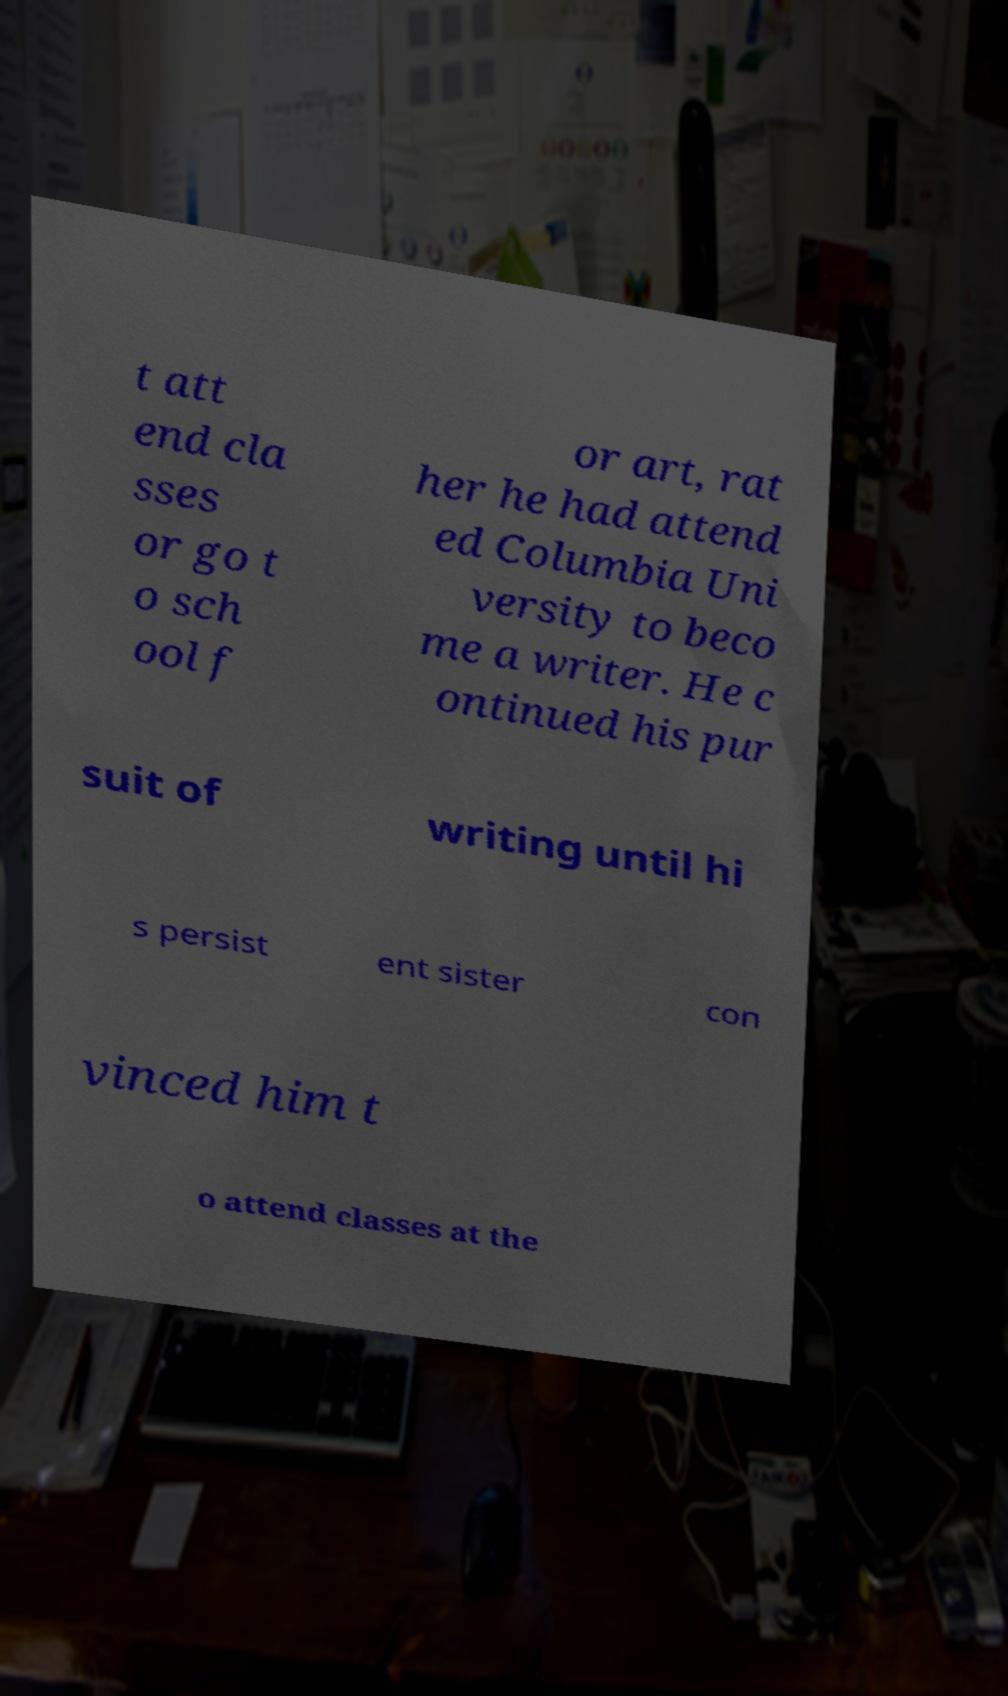Please read and relay the text visible in this image. What does it say? t att end cla sses or go t o sch ool f or art, rat her he had attend ed Columbia Uni versity to beco me a writer. He c ontinued his pur suit of writing until hi s persist ent sister con vinced him t o attend classes at the 